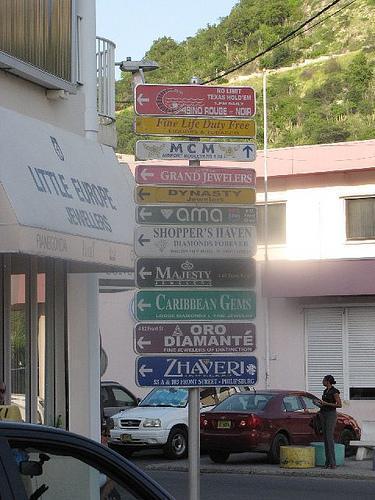How many signs are on this post?
Give a very brief answer. 11. How many cars are there?
Give a very brief answer. 2. How many dogs are there?
Give a very brief answer. 0. 